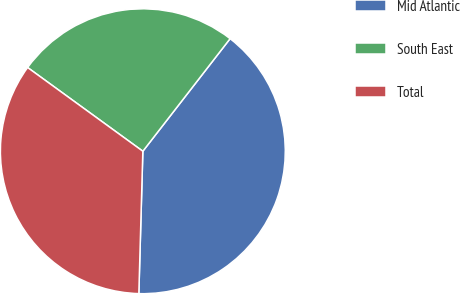<chart> <loc_0><loc_0><loc_500><loc_500><pie_chart><fcel>Mid Atlantic<fcel>South East<fcel>Total<nl><fcel>39.95%<fcel>25.49%<fcel>34.55%<nl></chart> 